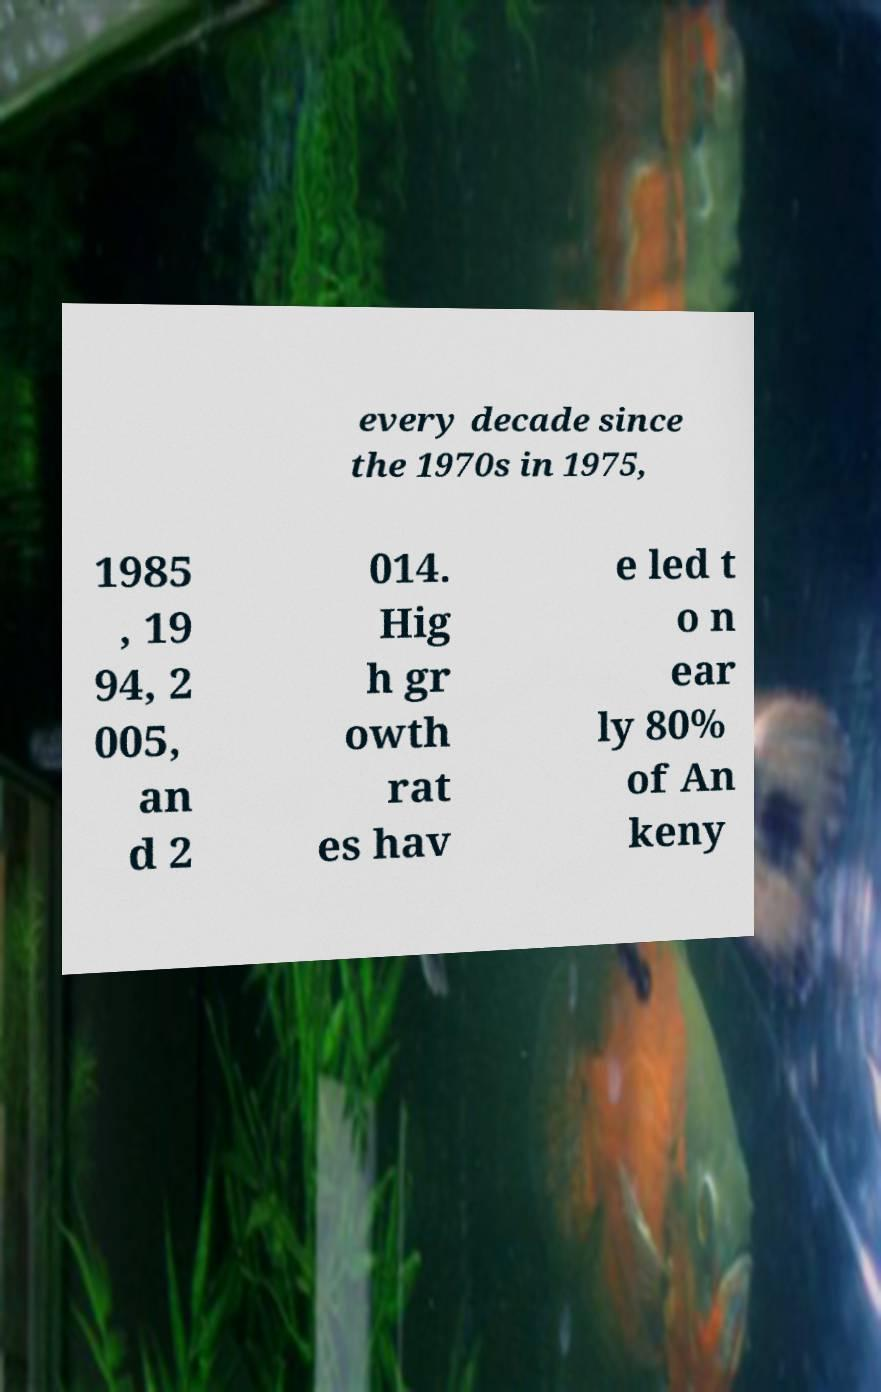Can you accurately transcribe the text from the provided image for me? every decade since the 1970s in 1975, 1985 , 19 94, 2 005, an d 2 014. Hig h gr owth rat es hav e led t o n ear ly 80% of An keny 